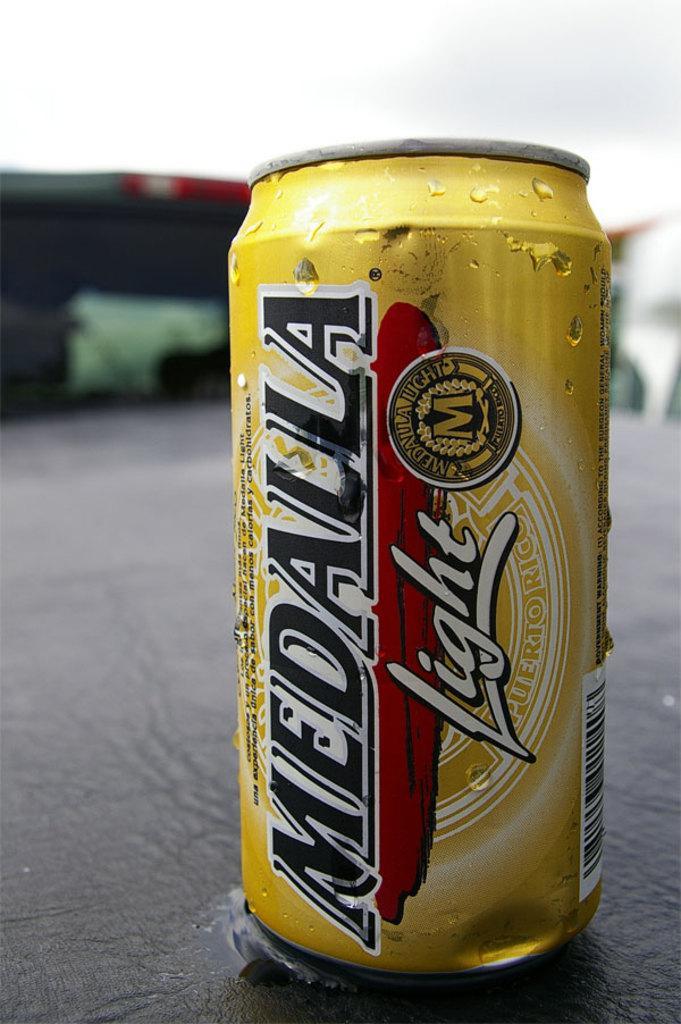Describe this image in one or two sentences. There is a golden color tin on which, there are some texts, designs and barcode printed, on the table. And the background is blurred. 